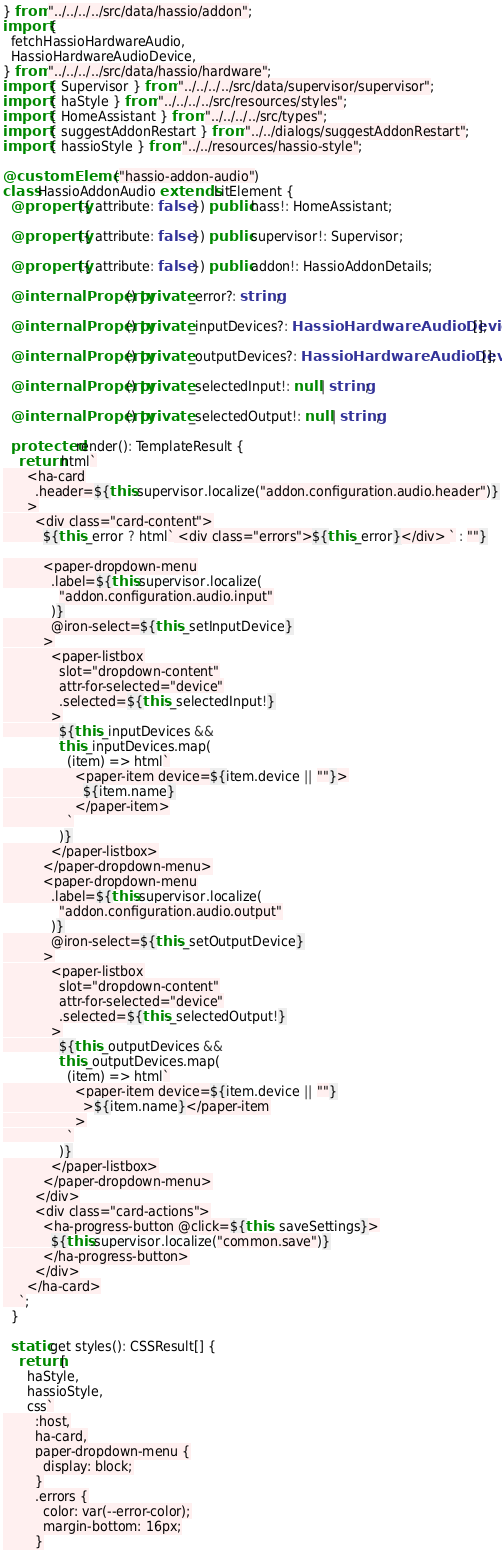<code> <loc_0><loc_0><loc_500><loc_500><_TypeScript_>} from "../../../../src/data/hassio/addon";
import {
  fetchHassioHardwareAudio,
  HassioHardwareAudioDevice,
} from "../../../../src/data/hassio/hardware";
import { Supervisor } from "../../../../src/data/supervisor/supervisor";
import { haStyle } from "../../../../src/resources/styles";
import { HomeAssistant } from "../../../../src/types";
import { suggestAddonRestart } from "../../dialogs/suggestAddonRestart";
import { hassioStyle } from "../../resources/hassio-style";

@customElement("hassio-addon-audio")
class HassioAddonAudio extends LitElement {
  @property({ attribute: false }) public hass!: HomeAssistant;

  @property({ attribute: false }) public supervisor!: Supervisor;

  @property({ attribute: false }) public addon!: HassioAddonDetails;

  @internalProperty() private _error?: string;

  @internalProperty() private _inputDevices?: HassioHardwareAudioDevice[];

  @internalProperty() private _outputDevices?: HassioHardwareAudioDevice[];

  @internalProperty() private _selectedInput!: null | string;

  @internalProperty() private _selectedOutput!: null | string;

  protected render(): TemplateResult {
    return html`
      <ha-card
        .header=${this.supervisor.localize("addon.configuration.audio.header")}
      >
        <div class="card-content">
          ${this._error ? html` <div class="errors">${this._error}</div> ` : ""}

          <paper-dropdown-menu
            .label=${this.supervisor.localize(
              "addon.configuration.audio.input"
            )}
            @iron-select=${this._setInputDevice}
          >
            <paper-listbox
              slot="dropdown-content"
              attr-for-selected="device"
              .selected=${this._selectedInput!}
            >
              ${this._inputDevices &&
              this._inputDevices.map(
                (item) => html`
                  <paper-item device=${item.device || ""}>
                    ${item.name}
                  </paper-item>
                `
              )}
            </paper-listbox>
          </paper-dropdown-menu>
          <paper-dropdown-menu
            .label=${this.supervisor.localize(
              "addon.configuration.audio.output"
            )}
            @iron-select=${this._setOutputDevice}
          >
            <paper-listbox
              slot="dropdown-content"
              attr-for-selected="device"
              .selected=${this._selectedOutput!}
            >
              ${this._outputDevices &&
              this._outputDevices.map(
                (item) => html`
                  <paper-item device=${item.device || ""}
                    >${item.name}</paper-item
                  >
                `
              )}
            </paper-listbox>
          </paper-dropdown-menu>
        </div>
        <div class="card-actions">
          <ha-progress-button @click=${this._saveSettings}>
            ${this.supervisor.localize("common.save")}
          </ha-progress-button>
        </div>
      </ha-card>
    `;
  }

  static get styles(): CSSResult[] {
    return [
      haStyle,
      hassioStyle,
      css`
        :host,
        ha-card,
        paper-dropdown-menu {
          display: block;
        }
        .errors {
          color: var(--error-color);
          margin-bottom: 16px;
        }</code> 